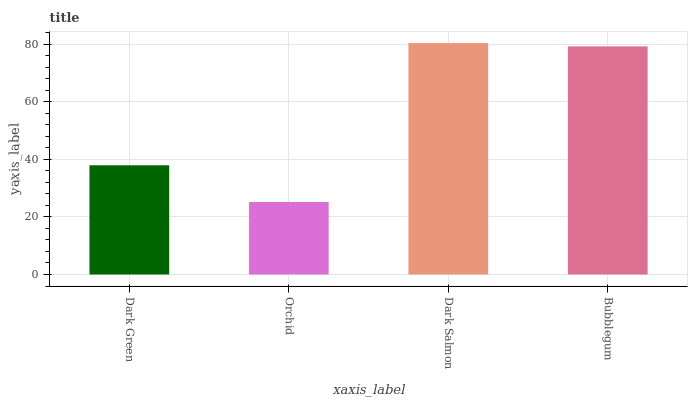Is Orchid the minimum?
Answer yes or no. Yes. Is Dark Salmon the maximum?
Answer yes or no. Yes. Is Dark Salmon the minimum?
Answer yes or no. No. Is Orchid the maximum?
Answer yes or no. No. Is Dark Salmon greater than Orchid?
Answer yes or no. Yes. Is Orchid less than Dark Salmon?
Answer yes or no. Yes. Is Orchid greater than Dark Salmon?
Answer yes or no. No. Is Dark Salmon less than Orchid?
Answer yes or no. No. Is Bubblegum the high median?
Answer yes or no. Yes. Is Dark Green the low median?
Answer yes or no. Yes. Is Orchid the high median?
Answer yes or no. No. Is Dark Salmon the low median?
Answer yes or no. No. 